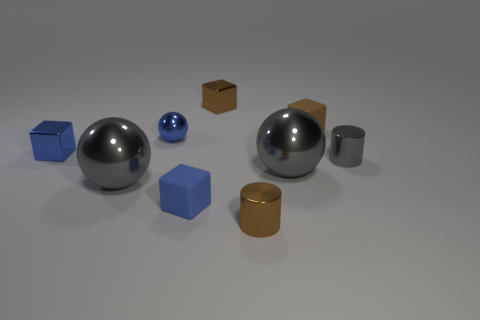There is a large object that is left of the big gray object to the right of the blue metallic sphere; what is its material?
Provide a short and direct response. Metal. Is the number of shiny spheres that are on the right side of the tiny sphere the same as the number of brown matte objects?
Give a very brief answer. Yes. How big is the cube that is both on the right side of the tiny sphere and in front of the small brown rubber thing?
Offer a very short reply. Small. There is a large metal sphere that is to the right of the gray object that is to the left of the brown metallic block; what color is it?
Your response must be concise. Gray. How many gray objects are small spheres or large spheres?
Your response must be concise. 2. The tiny metal thing that is in front of the small blue metal block and on the left side of the brown matte block is what color?
Provide a succinct answer. Brown. How many large objects are gray metallic spheres or blue objects?
Keep it short and to the point. 2. There is a blue metallic object that is the same shape as the tiny brown rubber thing; what size is it?
Give a very brief answer. Small. What shape is the small blue matte thing?
Give a very brief answer. Cube. Is the material of the gray cylinder the same as the sphere that is on the right side of the tiny blue rubber block?
Ensure brevity in your answer.  Yes. 